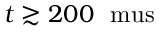<formula> <loc_0><loc_0><loc_500><loc_500>t \gtrsim 2 0 0 \ m u s</formula> 